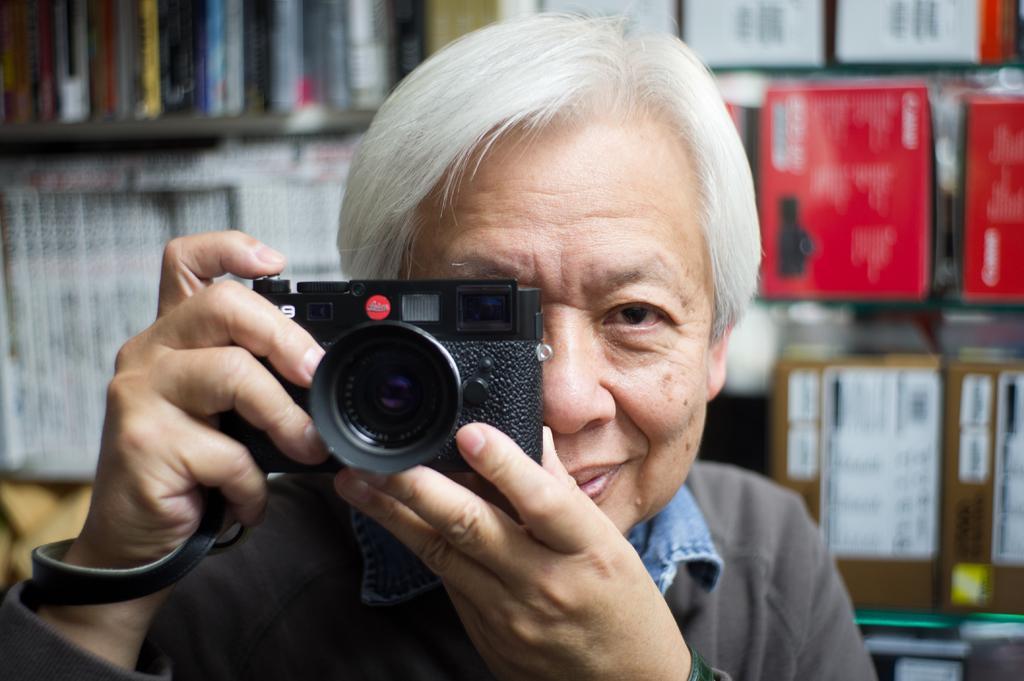In one or two sentences, can you explain what this image depicts? In this image we have a man who is holding a camera in his hands and smiling. Behind the man we can see a shelf with some objects in it. 